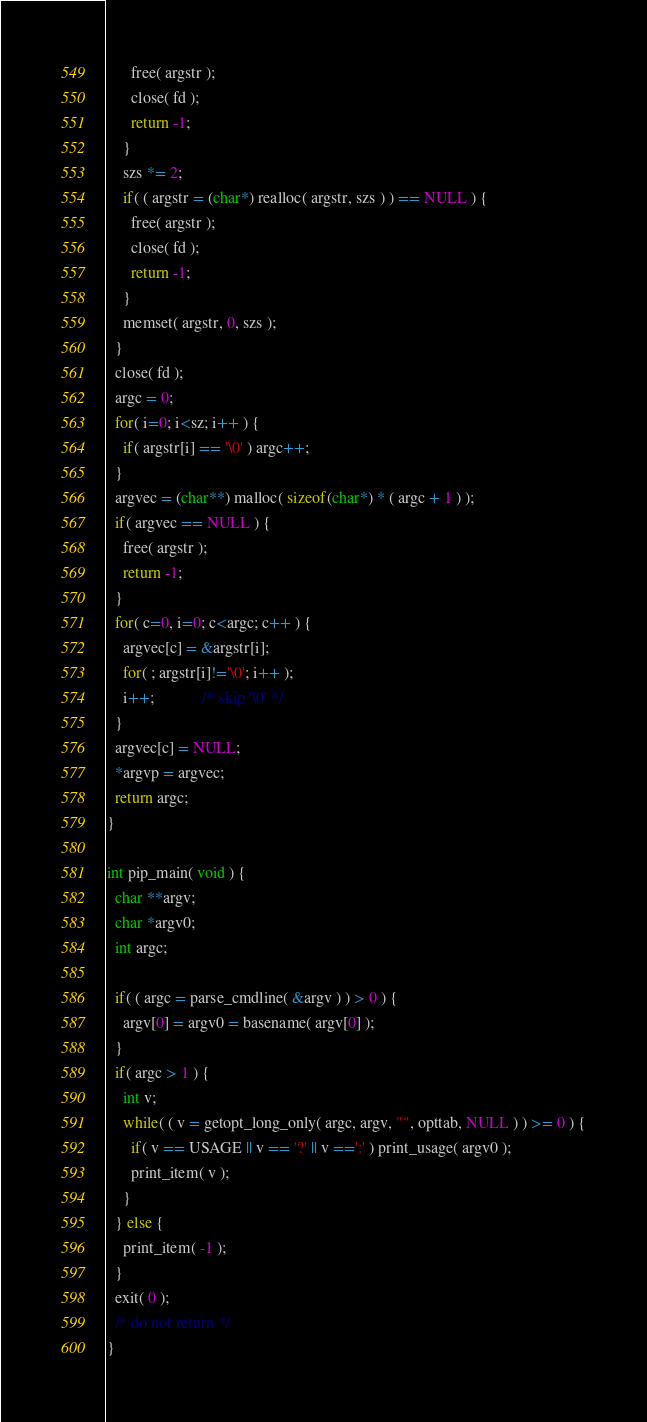<code> <loc_0><loc_0><loc_500><loc_500><_C_>      free( argstr );
      close( fd );
      return -1;
    }
    szs *= 2;
    if( ( argstr = (char*) realloc( argstr, szs ) ) == NULL ) {
      free( argstr );
      close( fd );
      return -1;
    }
    memset( argstr, 0, szs );
  }
  close( fd );
  argc = 0;
  for( i=0; i<sz; i++ ) {
    if( argstr[i] == '\0' ) argc++;
  }
  argvec = (char**) malloc( sizeof(char*) * ( argc + 1 ) );
  if( argvec == NULL ) {
    free( argstr );
    return -1;
  }
  for( c=0, i=0; c<argc; c++ ) {
    argvec[c] = &argstr[i];
    for( ; argstr[i]!='\0'; i++ );
    i++;			/* skip '\0' */
  }
  argvec[c] = NULL;
  *argvp = argvec;
  return argc;
}

int pip_main( void ) {
  char **argv;
  char *argv0;
  int argc;

  if( ( argc = parse_cmdline( &argv ) ) > 0 ) {
    argv[0] = argv0 = basename( argv[0] );
  }
  if( argc > 1 ) {
    int v;
    while( ( v = getopt_long_only( argc, argv, "", opttab, NULL ) ) >= 0 ) {
      if( v == USAGE || v == '?' || v ==':' ) print_usage( argv0 );
      print_item( v );
    }
  } else {
    print_item( -1 );
  }
  exit( 0 );
  /* do not return */
}
</code> 